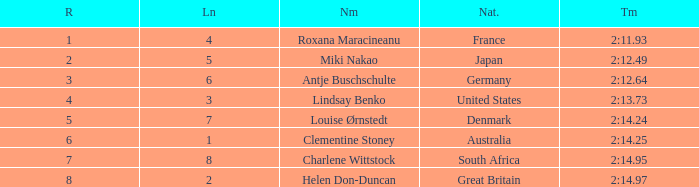What is the number of lane with a rank more than 2 for louise ørnstedt? 1.0. 